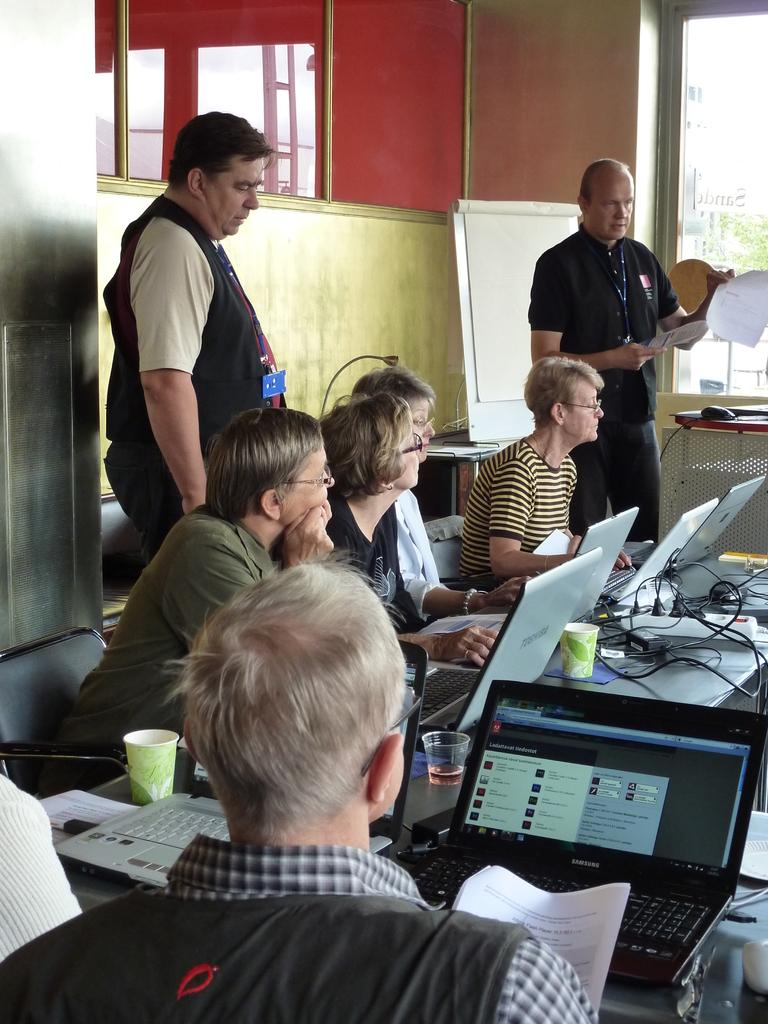How many people are in the image? There is a group of people in the image. What are the people doing in the image? The people are sitting on chairs in front of a table. What is on the table in the image? There are systems and glasses on the table. Are there any people standing in the image? Yes, two people are standing behind the seated group. What type of account is being discussed by the people in the image? There is no indication in the image that the people are discussing any type of account. Can you see any ants crawling on the table in the image? There are no ants visible in the image. 